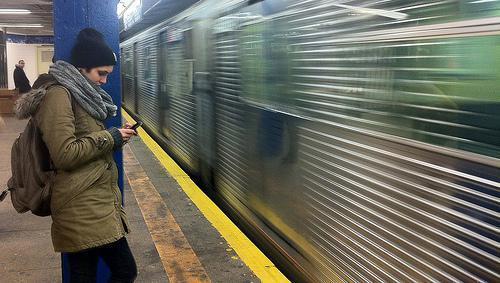How many people are in the picture?
Give a very brief answer. 2. How many people?
Give a very brief answer. 2. How many trains?
Give a very brief answer. 1. 